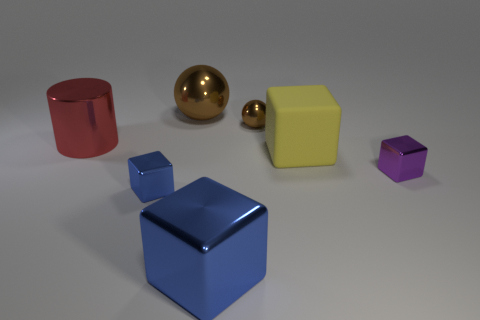Subtract 1 cubes. How many cubes are left? 3 Add 1 purple matte cylinders. How many objects exist? 8 Subtract all spheres. How many objects are left? 5 Subtract 0 green spheres. How many objects are left? 7 Subtract all purple shiny cubes. Subtract all big brown things. How many objects are left? 5 Add 6 red things. How many red things are left? 7 Add 2 big purple metal cubes. How many big purple metal cubes exist? 2 